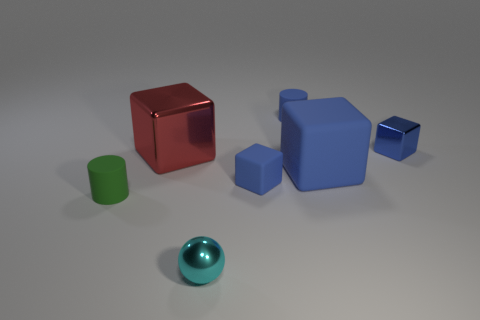There is a thing that is both behind the big red cube and on the left side of the small blue shiny thing; what material is it?
Give a very brief answer. Rubber. There is a small block that is to the left of the big thing that is on the right side of the small cyan metallic object; what color is it?
Make the answer very short. Blue. What material is the big cube that is to the right of the metallic ball?
Provide a succinct answer. Rubber. Is the number of blue blocks less than the number of red blocks?
Your answer should be compact. No. Do the small green matte object and the small blue rubber object behind the big red thing have the same shape?
Give a very brief answer. Yes. The thing that is behind the big red shiny thing and on the left side of the blue metallic object has what shape?
Your answer should be compact. Cylinder. Are there an equal number of shiny things that are in front of the large blue matte object and green matte things that are to the right of the cyan sphere?
Your response must be concise. No. There is a tiny shiny object behind the big shiny thing; is it the same shape as the big red metal object?
Offer a terse response. Yes. How many purple objects are cubes or small objects?
Your answer should be compact. 0. What material is the other large object that is the same shape as the large rubber thing?
Give a very brief answer. Metal. 